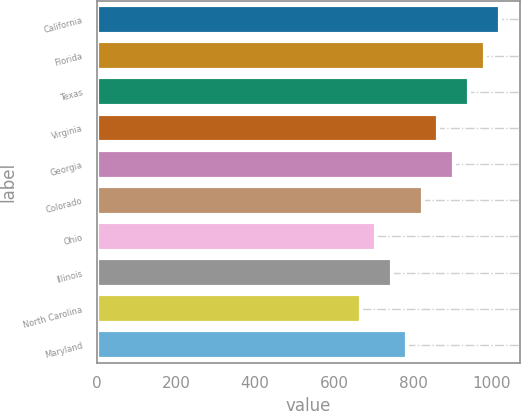Convert chart. <chart><loc_0><loc_0><loc_500><loc_500><bar_chart><fcel>California<fcel>Florida<fcel>Texas<fcel>Virginia<fcel>Georgia<fcel>Colorado<fcel>Ohio<fcel>Illinois<fcel>North Carolina<fcel>Maryland<nl><fcel>1020.2<fcel>981<fcel>941.8<fcel>863.4<fcel>902.6<fcel>824.2<fcel>706.6<fcel>745.8<fcel>667.4<fcel>785<nl></chart> 